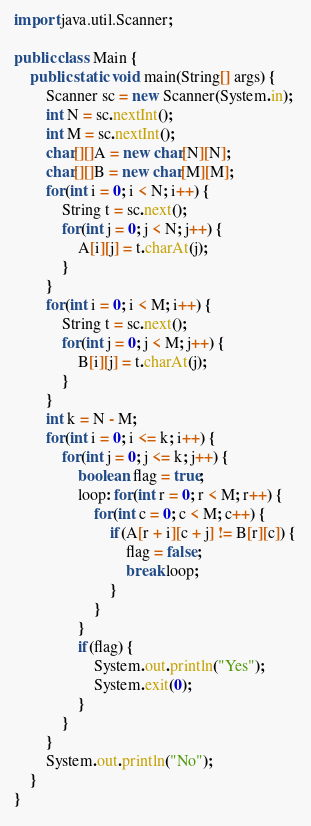Convert code to text. <code><loc_0><loc_0><loc_500><loc_500><_Java_>import java.util.Scanner;

public class Main {
	public static void main(String[] args) {
		Scanner sc = new Scanner(System.in);
		int N = sc.nextInt();
		int M = sc.nextInt();
		char[][]A = new char[N][N];
		char[][]B = new char[M][M];
		for(int i = 0; i < N; i++) {
			String t = sc.next();
			for(int j = 0; j < N; j++) {
				A[i][j] = t.charAt(j);
			}
		}
		for(int i = 0; i < M; i++) {
			String t = sc.next();
			for(int j = 0; j < M; j++) {
				B[i][j] = t.charAt(j);
			}
		}
		int k = N - M;
		for(int i = 0; i <= k; i++) {
			for(int j = 0; j <= k; j++) {
				boolean flag = true;
				loop: for(int r = 0; r < M; r++) {
					for(int c = 0; c < M; c++) {
						if(A[r + i][c + j] != B[r][c]) {
							flag = false;
							break loop;
						}
					}
				}
				if(flag) {
					System.out.println("Yes");
					System.exit(0);
				}
			}
		}
		System.out.println("No");
	}
}
</code> 